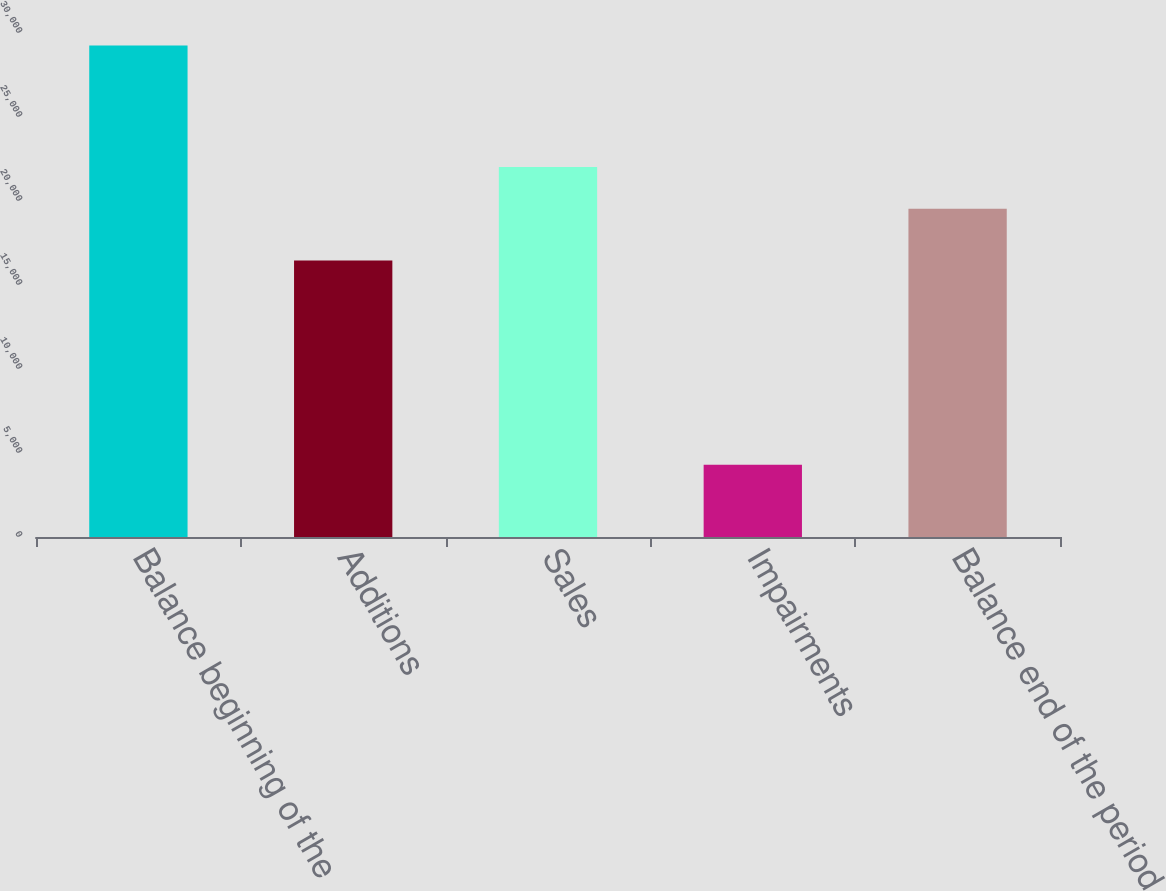<chart> <loc_0><loc_0><loc_500><loc_500><bar_chart><fcel>Balance beginning of the<fcel>Additions<fcel>Sales<fcel>Impairments<fcel>Balance end of the period<nl><fcel>29252<fcel>16463<fcel>22027.8<fcel>4294<fcel>19532<nl></chart> 